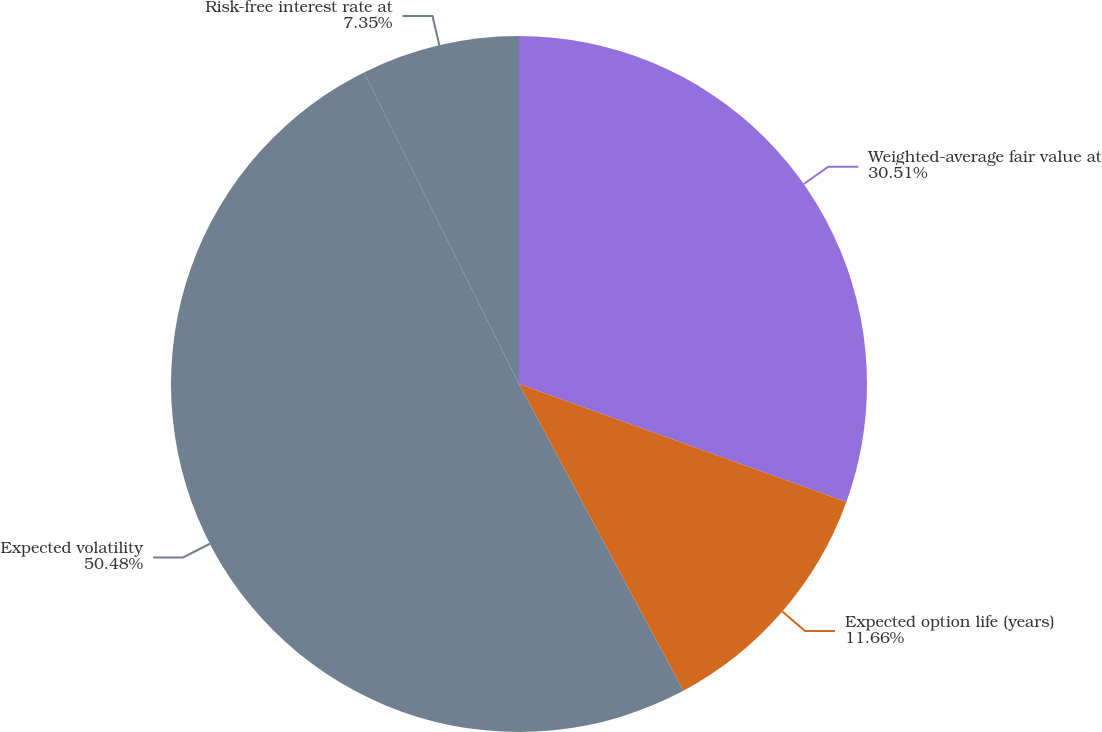<chart> <loc_0><loc_0><loc_500><loc_500><pie_chart><fcel>Weighted-average fair value at<fcel>Expected option life (years)<fcel>Expected volatility<fcel>Risk-free interest rate at<nl><fcel>30.51%<fcel>11.66%<fcel>50.48%<fcel>7.35%<nl></chart> 